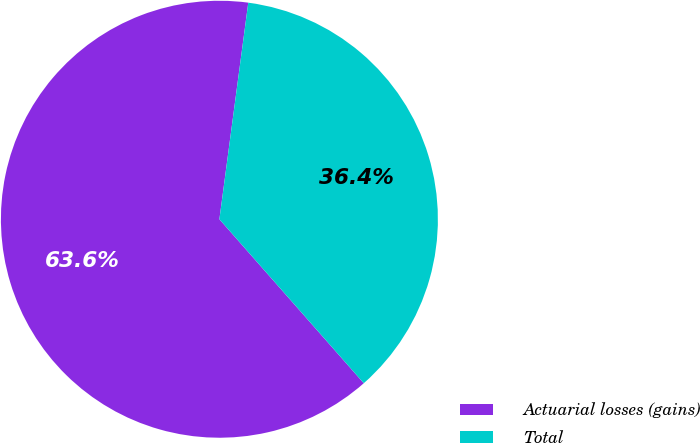Convert chart. <chart><loc_0><loc_0><loc_500><loc_500><pie_chart><fcel>Actuarial losses (gains)<fcel>Total<nl><fcel>63.6%<fcel>36.4%<nl></chart> 